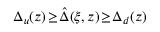<formula> <loc_0><loc_0><loc_500><loc_500>\Delta _ { u } ( z ) \, \geq \, \hat { \Delta } ( \xi , z ) \, \geq \, \Delta _ { d } ( z )</formula> 